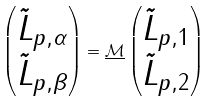Convert formula to latex. <formula><loc_0><loc_0><loc_500><loc_500>\begin{pmatrix} \tilde { L } _ { p , \alpha } \\ \tilde { L } _ { p , \beta } \end{pmatrix} = \underline { \mathcal { M } } \begin{pmatrix} \tilde { L } _ { p , 1 } \\ \tilde { L } _ { p , 2 } \end{pmatrix}</formula> 